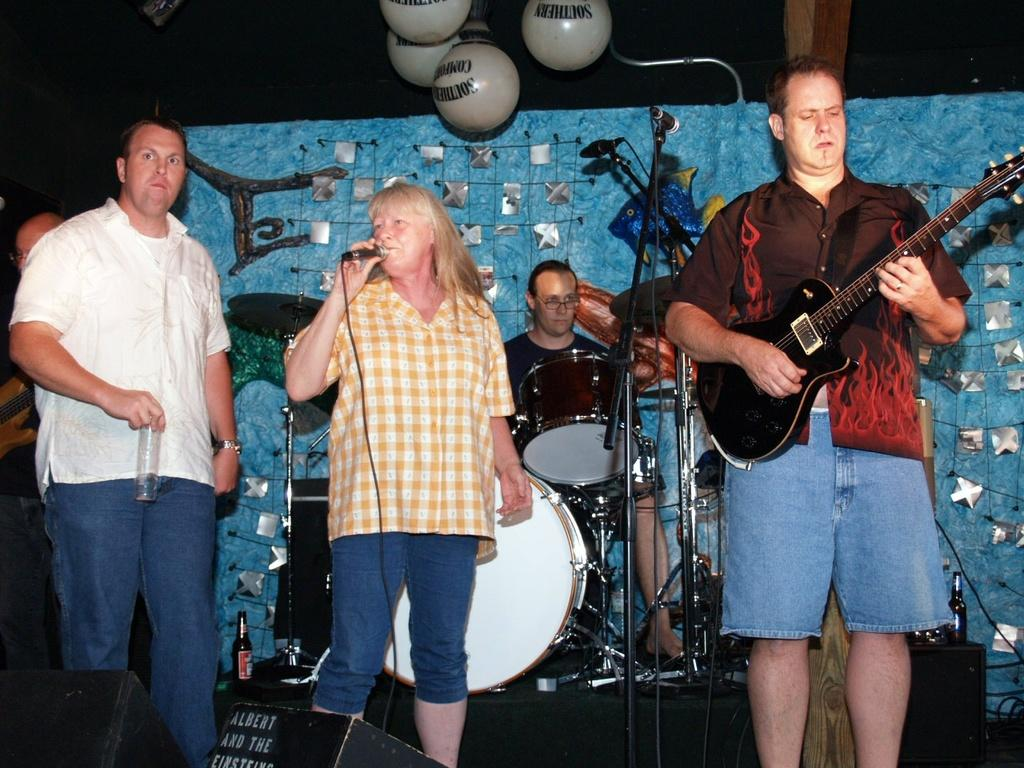How many people are on the stage in the image? There are four people on the stage in the image. What are the people on the stage doing? The people on the stage are playing musical instruments. What can be seen above the people on the stage? There are lamps above the people on the stage. What colors are used on the back wall of the stage? The back wall has a blue and silver color scheme. Can you see any fairies playing the string instruments in the image? There are no fairies present in the image; the people playing the musical instruments are human. How does the wind blow the instruments in the image? There is no wind blowing the instruments in the image; the people are playing them. 